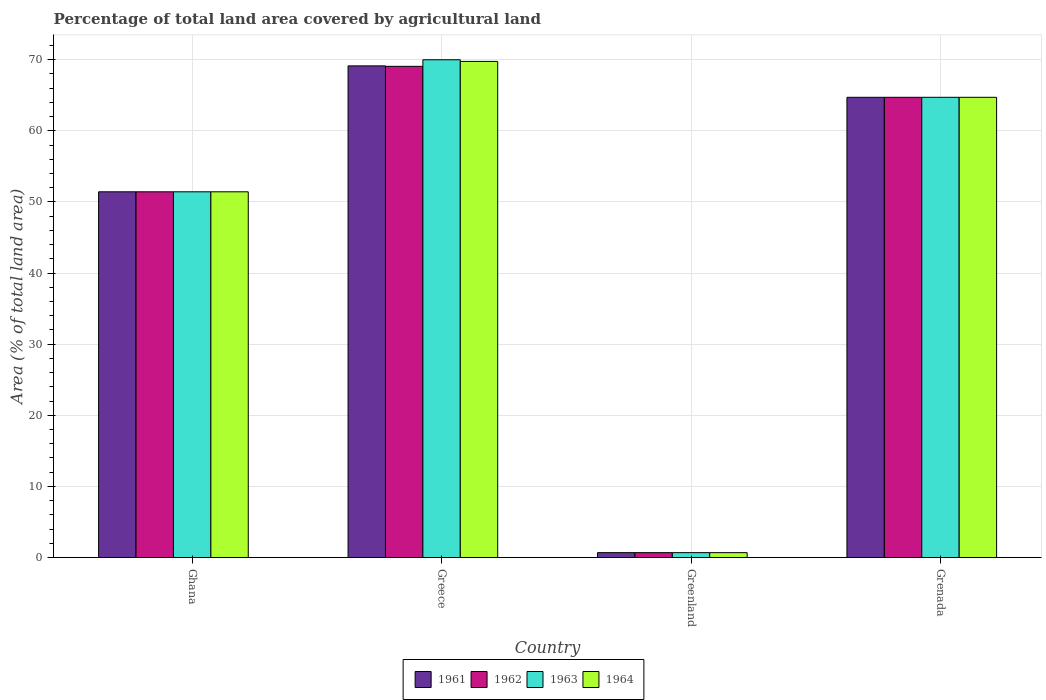How many different coloured bars are there?
Provide a short and direct response. 4. Are the number of bars per tick equal to the number of legend labels?
Keep it short and to the point. Yes. How many bars are there on the 2nd tick from the left?
Make the answer very short. 4. What is the percentage of agricultural land in 1963 in Grenada?
Offer a terse response. 64.71. Across all countries, what is the maximum percentage of agricultural land in 1962?
Ensure brevity in your answer.  69.06. Across all countries, what is the minimum percentage of agricultural land in 1963?
Make the answer very short. 0.69. In which country was the percentage of agricultural land in 1964 maximum?
Your answer should be compact. Greece. In which country was the percentage of agricultural land in 1964 minimum?
Your response must be concise. Greenland. What is the total percentage of agricultural land in 1964 in the graph?
Provide a short and direct response. 186.56. What is the difference between the percentage of agricultural land in 1964 in Greece and that in Greenland?
Your response must be concise. 69.06. What is the difference between the percentage of agricultural land in 1964 in Greenland and the percentage of agricultural land in 1963 in Greece?
Offer a very short reply. -69.3. What is the average percentage of agricultural land in 1961 per country?
Give a very brief answer. 46.48. What is the ratio of the percentage of agricultural land in 1963 in Greenland to that in Grenada?
Provide a succinct answer. 0.01. Is the percentage of agricultural land in 1964 in Greenland less than that in Grenada?
Offer a terse response. Yes. Is the difference between the percentage of agricultural land in 1961 in Greece and Grenada greater than the difference between the percentage of agricultural land in 1962 in Greece and Grenada?
Ensure brevity in your answer.  Yes. What is the difference between the highest and the second highest percentage of agricultural land in 1963?
Your answer should be very brief. 13.29. What is the difference between the highest and the lowest percentage of agricultural land in 1964?
Provide a succinct answer. 69.06. Is it the case that in every country, the sum of the percentage of agricultural land in 1963 and percentage of agricultural land in 1961 is greater than the sum of percentage of agricultural land in 1964 and percentage of agricultural land in 1962?
Provide a succinct answer. No. What does the 1st bar from the left in Greece represents?
Keep it short and to the point. 1961. What does the 1st bar from the right in Greenland represents?
Give a very brief answer. 1964. How many countries are there in the graph?
Offer a very short reply. 4. Does the graph contain grids?
Ensure brevity in your answer.  Yes. How many legend labels are there?
Your answer should be compact. 4. What is the title of the graph?
Offer a very short reply. Percentage of total land area covered by agricultural land. What is the label or title of the X-axis?
Offer a very short reply. Country. What is the label or title of the Y-axis?
Provide a succinct answer. Area (% of total land area). What is the Area (% of total land area) in 1961 in Ghana?
Keep it short and to the point. 51.42. What is the Area (% of total land area) of 1962 in Ghana?
Make the answer very short. 51.42. What is the Area (% of total land area) in 1963 in Ghana?
Make the answer very short. 51.42. What is the Area (% of total land area) of 1964 in Ghana?
Your answer should be compact. 51.42. What is the Area (% of total land area) in 1961 in Greece?
Offer a terse response. 69.12. What is the Area (% of total land area) of 1962 in Greece?
Your answer should be very brief. 69.06. What is the Area (% of total land area) of 1963 in Greece?
Your answer should be very brief. 69.98. What is the Area (% of total land area) of 1964 in Greece?
Your answer should be very brief. 69.75. What is the Area (% of total land area) of 1961 in Greenland?
Keep it short and to the point. 0.69. What is the Area (% of total land area) of 1962 in Greenland?
Give a very brief answer. 0.69. What is the Area (% of total land area) of 1963 in Greenland?
Ensure brevity in your answer.  0.69. What is the Area (% of total land area) in 1964 in Greenland?
Your answer should be very brief. 0.69. What is the Area (% of total land area) of 1961 in Grenada?
Your answer should be very brief. 64.71. What is the Area (% of total land area) in 1962 in Grenada?
Provide a short and direct response. 64.71. What is the Area (% of total land area) of 1963 in Grenada?
Your answer should be compact. 64.71. What is the Area (% of total land area) in 1964 in Grenada?
Ensure brevity in your answer.  64.71. Across all countries, what is the maximum Area (% of total land area) of 1961?
Ensure brevity in your answer.  69.12. Across all countries, what is the maximum Area (% of total land area) of 1962?
Offer a terse response. 69.06. Across all countries, what is the maximum Area (% of total land area) in 1963?
Your answer should be compact. 69.98. Across all countries, what is the maximum Area (% of total land area) in 1964?
Provide a succinct answer. 69.75. Across all countries, what is the minimum Area (% of total land area) of 1961?
Give a very brief answer. 0.69. Across all countries, what is the minimum Area (% of total land area) in 1962?
Make the answer very short. 0.69. Across all countries, what is the minimum Area (% of total land area) of 1963?
Your answer should be compact. 0.69. Across all countries, what is the minimum Area (% of total land area) in 1964?
Provide a short and direct response. 0.69. What is the total Area (% of total land area) in 1961 in the graph?
Offer a terse response. 185.94. What is the total Area (% of total land area) in 1962 in the graph?
Offer a terse response. 185.87. What is the total Area (% of total land area) of 1963 in the graph?
Provide a succinct answer. 186.8. What is the total Area (% of total land area) of 1964 in the graph?
Keep it short and to the point. 186.56. What is the difference between the Area (% of total land area) of 1961 in Ghana and that in Greece?
Offer a very short reply. -17.7. What is the difference between the Area (% of total land area) of 1962 in Ghana and that in Greece?
Your response must be concise. -17.64. What is the difference between the Area (% of total land area) of 1963 in Ghana and that in Greece?
Your response must be concise. -18.57. What is the difference between the Area (% of total land area) in 1964 in Ghana and that in Greece?
Ensure brevity in your answer.  -18.33. What is the difference between the Area (% of total land area) in 1961 in Ghana and that in Greenland?
Make the answer very short. 50.73. What is the difference between the Area (% of total land area) of 1962 in Ghana and that in Greenland?
Keep it short and to the point. 50.73. What is the difference between the Area (% of total land area) in 1963 in Ghana and that in Greenland?
Your response must be concise. 50.73. What is the difference between the Area (% of total land area) of 1964 in Ghana and that in Greenland?
Your response must be concise. 50.73. What is the difference between the Area (% of total land area) in 1961 in Ghana and that in Grenada?
Make the answer very short. -13.29. What is the difference between the Area (% of total land area) of 1962 in Ghana and that in Grenada?
Make the answer very short. -13.29. What is the difference between the Area (% of total land area) of 1963 in Ghana and that in Grenada?
Your answer should be very brief. -13.29. What is the difference between the Area (% of total land area) of 1964 in Ghana and that in Grenada?
Your answer should be compact. -13.29. What is the difference between the Area (% of total land area) of 1961 in Greece and that in Greenland?
Ensure brevity in your answer.  68.44. What is the difference between the Area (% of total land area) in 1962 in Greece and that in Greenland?
Offer a terse response. 68.37. What is the difference between the Area (% of total land area) in 1963 in Greece and that in Greenland?
Offer a very short reply. 69.3. What is the difference between the Area (% of total land area) of 1964 in Greece and that in Greenland?
Provide a succinct answer. 69.06. What is the difference between the Area (% of total land area) in 1961 in Greece and that in Grenada?
Your answer should be very brief. 4.42. What is the difference between the Area (% of total land area) of 1962 in Greece and that in Grenada?
Offer a very short reply. 4.36. What is the difference between the Area (% of total land area) in 1963 in Greece and that in Grenada?
Offer a terse response. 5.28. What is the difference between the Area (% of total land area) of 1964 in Greece and that in Grenada?
Provide a short and direct response. 5.05. What is the difference between the Area (% of total land area) of 1961 in Greenland and that in Grenada?
Keep it short and to the point. -64.02. What is the difference between the Area (% of total land area) of 1962 in Greenland and that in Grenada?
Your answer should be compact. -64.02. What is the difference between the Area (% of total land area) of 1963 in Greenland and that in Grenada?
Provide a succinct answer. -64.02. What is the difference between the Area (% of total land area) in 1964 in Greenland and that in Grenada?
Offer a terse response. -64.02. What is the difference between the Area (% of total land area) of 1961 in Ghana and the Area (% of total land area) of 1962 in Greece?
Offer a very short reply. -17.64. What is the difference between the Area (% of total land area) of 1961 in Ghana and the Area (% of total land area) of 1963 in Greece?
Offer a very short reply. -18.57. What is the difference between the Area (% of total land area) of 1961 in Ghana and the Area (% of total land area) of 1964 in Greece?
Your answer should be very brief. -18.33. What is the difference between the Area (% of total land area) of 1962 in Ghana and the Area (% of total land area) of 1963 in Greece?
Make the answer very short. -18.57. What is the difference between the Area (% of total land area) of 1962 in Ghana and the Area (% of total land area) of 1964 in Greece?
Provide a succinct answer. -18.33. What is the difference between the Area (% of total land area) in 1963 in Ghana and the Area (% of total land area) in 1964 in Greece?
Your answer should be compact. -18.33. What is the difference between the Area (% of total land area) of 1961 in Ghana and the Area (% of total land area) of 1962 in Greenland?
Provide a short and direct response. 50.73. What is the difference between the Area (% of total land area) in 1961 in Ghana and the Area (% of total land area) in 1963 in Greenland?
Your response must be concise. 50.73. What is the difference between the Area (% of total land area) in 1961 in Ghana and the Area (% of total land area) in 1964 in Greenland?
Ensure brevity in your answer.  50.73. What is the difference between the Area (% of total land area) of 1962 in Ghana and the Area (% of total land area) of 1963 in Greenland?
Your response must be concise. 50.73. What is the difference between the Area (% of total land area) of 1962 in Ghana and the Area (% of total land area) of 1964 in Greenland?
Your answer should be very brief. 50.73. What is the difference between the Area (% of total land area) of 1963 in Ghana and the Area (% of total land area) of 1964 in Greenland?
Make the answer very short. 50.73. What is the difference between the Area (% of total land area) of 1961 in Ghana and the Area (% of total land area) of 1962 in Grenada?
Offer a terse response. -13.29. What is the difference between the Area (% of total land area) in 1961 in Ghana and the Area (% of total land area) in 1963 in Grenada?
Provide a succinct answer. -13.29. What is the difference between the Area (% of total land area) in 1961 in Ghana and the Area (% of total land area) in 1964 in Grenada?
Make the answer very short. -13.29. What is the difference between the Area (% of total land area) of 1962 in Ghana and the Area (% of total land area) of 1963 in Grenada?
Make the answer very short. -13.29. What is the difference between the Area (% of total land area) in 1962 in Ghana and the Area (% of total land area) in 1964 in Grenada?
Provide a succinct answer. -13.29. What is the difference between the Area (% of total land area) of 1963 in Ghana and the Area (% of total land area) of 1964 in Grenada?
Provide a short and direct response. -13.29. What is the difference between the Area (% of total land area) of 1961 in Greece and the Area (% of total land area) of 1962 in Greenland?
Your answer should be very brief. 68.44. What is the difference between the Area (% of total land area) in 1961 in Greece and the Area (% of total land area) in 1963 in Greenland?
Your answer should be very brief. 68.44. What is the difference between the Area (% of total land area) of 1961 in Greece and the Area (% of total land area) of 1964 in Greenland?
Make the answer very short. 68.44. What is the difference between the Area (% of total land area) of 1962 in Greece and the Area (% of total land area) of 1963 in Greenland?
Provide a short and direct response. 68.37. What is the difference between the Area (% of total land area) in 1962 in Greece and the Area (% of total land area) in 1964 in Greenland?
Offer a very short reply. 68.37. What is the difference between the Area (% of total land area) in 1963 in Greece and the Area (% of total land area) in 1964 in Greenland?
Make the answer very short. 69.3. What is the difference between the Area (% of total land area) of 1961 in Greece and the Area (% of total land area) of 1962 in Grenada?
Offer a very short reply. 4.42. What is the difference between the Area (% of total land area) of 1961 in Greece and the Area (% of total land area) of 1963 in Grenada?
Your response must be concise. 4.42. What is the difference between the Area (% of total land area) in 1961 in Greece and the Area (% of total land area) in 1964 in Grenada?
Offer a terse response. 4.42. What is the difference between the Area (% of total land area) in 1962 in Greece and the Area (% of total land area) in 1963 in Grenada?
Give a very brief answer. 4.36. What is the difference between the Area (% of total land area) in 1962 in Greece and the Area (% of total land area) in 1964 in Grenada?
Your response must be concise. 4.36. What is the difference between the Area (% of total land area) of 1963 in Greece and the Area (% of total land area) of 1964 in Grenada?
Your answer should be very brief. 5.28. What is the difference between the Area (% of total land area) in 1961 in Greenland and the Area (% of total land area) in 1962 in Grenada?
Offer a terse response. -64.02. What is the difference between the Area (% of total land area) of 1961 in Greenland and the Area (% of total land area) of 1963 in Grenada?
Keep it short and to the point. -64.02. What is the difference between the Area (% of total land area) in 1961 in Greenland and the Area (% of total land area) in 1964 in Grenada?
Keep it short and to the point. -64.02. What is the difference between the Area (% of total land area) of 1962 in Greenland and the Area (% of total land area) of 1963 in Grenada?
Provide a succinct answer. -64.02. What is the difference between the Area (% of total land area) in 1962 in Greenland and the Area (% of total land area) in 1964 in Grenada?
Provide a short and direct response. -64.02. What is the difference between the Area (% of total land area) of 1963 in Greenland and the Area (% of total land area) of 1964 in Grenada?
Offer a terse response. -64.02. What is the average Area (% of total land area) in 1961 per country?
Your answer should be compact. 46.48. What is the average Area (% of total land area) in 1962 per country?
Provide a succinct answer. 46.47. What is the average Area (% of total land area) of 1963 per country?
Give a very brief answer. 46.7. What is the average Area (% of total land area) of 1964 per country?
Give a very brief answer. 46.64. What is the difference between the Area (% of total land area) of 1961 and Area (% of total land area) of 1962 in Ghana?
Keep it short and to the point. 0. What is the difference between the Area (% of total land area) of 1961 and Area (% of total land area) of 1964 in Ghana?
Offer a terse response. 0. What is the difference between the Area (% of total land area) in 1961 and Area (% of total land area) in 1962 in Greece?
Provide a short and direct response. 0.06. What is the difference between the Area (% of total land area) of 1961 and Area (% of total land area) of 1963 in Greece?
Provide a succinct answer. -0.86. What is the difference between the Area (% of total land area) of 1961 and Area (% of total land area) of 1964 in Greece?
Ensure brevity in your answer.  -0.63. What is the difference between the Area (% of total land area) of 1962 and Area (% of total land area) of 1963 in Greece?
Keep it short and to the point. -0.92. What is the difference between the Area (% of total land area) of 1962 and Area (% of total land area) of 1964 in Greece?
Ensure brevity in your answer.  -0.69. What is the difference between the Area (% of total land area) in 1963 and Area (% of total land area) in 1964 in Greece?
Make the answer very short. 0.23. What is the difference between the Area (% of total land area) in 1961 and Area (% of total land area) in 1963 in Greenland?
Offer a terse response. 0. What is the difference between the Area (% of total land area) of 1961 and Area (% of total land area) of 1964 in Greenland?
Provide a short and direct response. 0. What is the difference between the Area (% of total land area) of 1962 and Area (% of total land area) of 1963 in Greenland?
Make the answer very short. 0. What is the difference between the Area (% of total land area) in 1962 and Area (% of total land area) in 1964 in Greenland?
Ensure brevity in your answer.  0. What is the difference between the Area (% of total land area) of 1961 and Area (% of total land area) of 1962 in Grenada?
Your answer should be very brief. 0. What is the difference between the Area (% of total land area) in 1961 and Area (% of total land area) in 1964 in Grenada?
Provide a succinct answer. 0. What is the difference between the Area (% of total land area) in 1962 and Area (% of total land area) in 1963 in Grenada?
Your answer should be very brief. 0. What is the ratio of the Area (% of total land area) in 1961 in Ghana to that in Greece?
Your answer should be very brief. 0.74. What is the ratio of the Area (% of total land area) in 1962 in Ghana to that in Greece?
Provide a short and direct response. 0.74. What is the ratio of the Area (% of total land area) of 1963 in Ghana to that in Greece?
Keep it short and to the point. 0.73. What is the ratio of the Area (% of total land area) in 1964 in Ghana to that in Greece?
Give a very brief answer. 0.74. What is the ratio of the Area (% of total land area) of 1961 in Ghana to that in Greenland?
Offer a terse response. 74.77. What is the ratio of the Area (% of total land area) of 1962 in Ghana to that in Greenland?
Give a very brief answer. 74.77. What is the ratio of the Area (% of total land area) in 1963 in Ghana to that in Greenland?
Your response must be concise. 74.77. What is the ratio of the Area (% of total land area) in 1964 in Ghana to that in Greenland?
Offer a terse response. 74.77. What is the ratio of the Area (% of total land area) of 1961 in Ghana to that in Grenada?
Ensure brevity in your answer.  0.79. What is the ratio of the Area (% of total land area) of 1962 in Ghana to that in Grenada?
Your answer should be compact. 0.79. What is the ratio of the Area (% of total land area) of 1963 in Ghana to that in Grenada?
Your response must be concise. 0.79. What is the ratio of the Area (% of total land area) of 1964 in Ghana to that in Grenada?
Your response must be concise. 0.79. What is the ratio of the Area (% of total land area) in 1961 in Greece to that in Greenland?
Make the answer very short. 100.51. What is the ratio of the Area (% of total land area) in 1962 in Greece to that in Greenland?
Offer a terse response. 100.42. What is the ratio of the Area (% of total land area) in 1963 in Greece to that in Greenland?
Make the answer very short. 101.76. What is the ratio of the Area (% of total land area) in 1964 in Greece to that in Greenland?
Make the answer very short. 101.42. What is the ratio of the Area (% of total land area) in 1961 in Greece to that in Grenada?
Offer a terse response. 1.07. What is the ratio of the Area (% of total land area) of 1962 in Greece to that in Grenada?
Provide a succinct answer. 1.07. What is the ratio of the Area (% of total land area) in 1963 in Greece to that in Grenada?
Offer a terse response. 1.08. What is the ratio of the Area (% of total land area) in 1964 in Greece to that in Grenada?
Offer a terse response. 1.08. What is the ratio of the Area (% of total land area) in 1961 in Greenland to that in Grenada?
Your answer should be compact. 0.01. What is the ratio of the Area (% of total land area) in 1962 in Greenland to that in Grenada?
Offer a very short reply. 0.01. What is the ratio of the Area (% of total land area) in 1963 in Greenland to that in Grenada?
Your answer should be very brief. 0.01. What is the ratio of the Area (% of total land area) in 1964 in Greenland to that in Grenada?
Offer a terse response. 0.01. What is the difference between the highest and the second highest Area (% of total land area) of 1961?
Provide a short and direct response. 4.42. What is the difference between the highest and the second highest Area (% of total land area) of 1962?
Offer a terse response. 4.36. What is the difference between the highest and the second highest Area (% of total land area) in 1963?
Give a very brief answer. 5.28. What is the difference between the highest and the second highest Area (% of total land area) in 1964?
Offer a very short reply. 5.05. What is the difference between the highest and the lowest Area (% of total land area) of 1961?
Provide a short and direct response. 68.44. What is the difference between the highest and the lowest Area (% of total land area) of 1962?
Provide a short and direct response. 68.37. What is the difference between the highest and the lowest Area (% of total land area) in 1963?
Offer a terse response. 69.3. What is the difference between the highest and the lowest Area (% of total land area) of 1964?
Give a very brief answer. 69.06. 